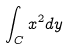<formula> <loc_0><loc_0><loc_500><loc_500>\int _ { C } x ^ { 2 } d y</formula> 